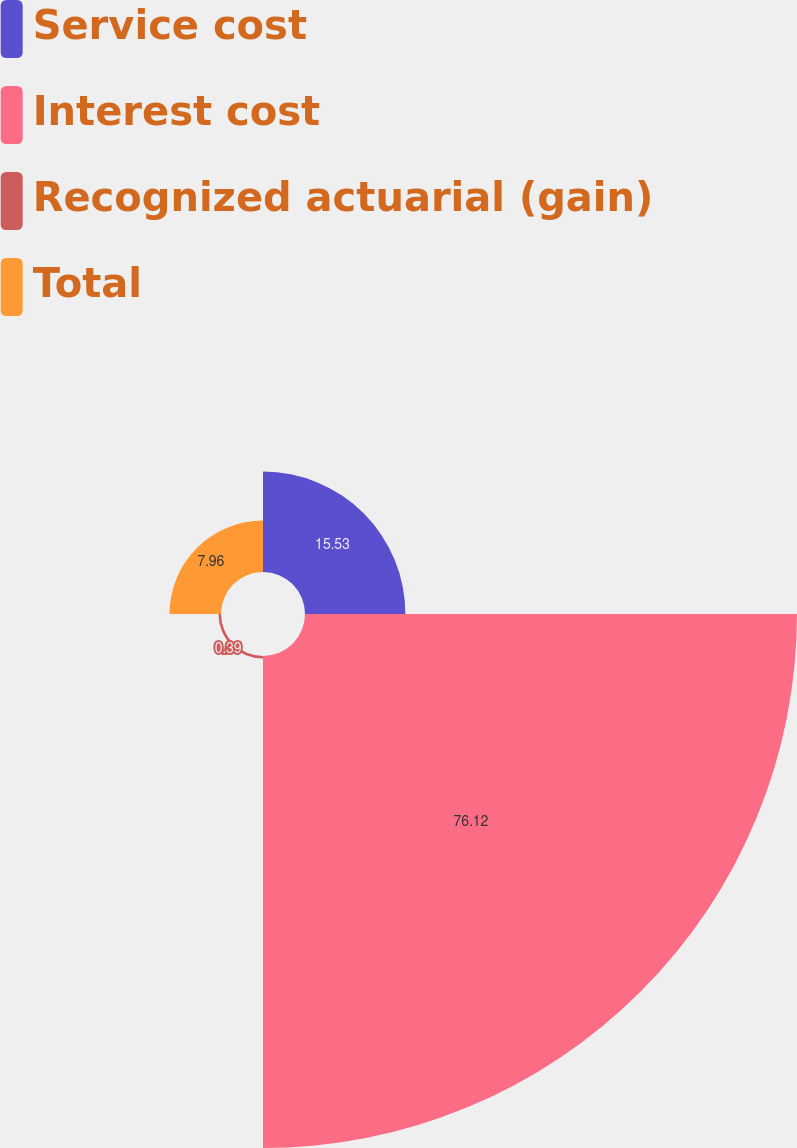Convert chart. <chart><loc_0><loc_0><loc_500><loc_500><pie_chart><fcel>Service cost<fcel>Interest cost<fcel>Recognized actuarial (gain)<fcel>Total<nl><fcel>15.53%<fcel>76.11%<fcel>0.39%<fcel>7.96%<nl></chart> 